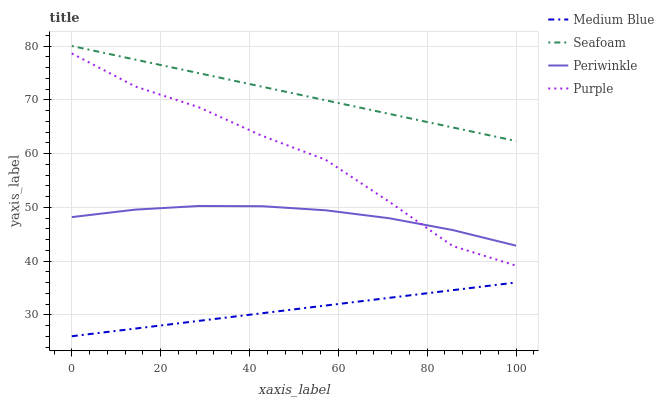Does Medium Blue have the minimum area under the curve?
Answer yes or no. Yes. Does Seafoam have the maximum area under the curve?
Answer yes or no. Yes. Does Periwinkle have the minimum area under the curve?
Answer yes or no. No. Does Periwinkle have the maximum area under the curve?
Answer yes or no. No. Is Medium Blue the smoothest?
Answer yes or no. Yes. Is Purple the roughest?
Answer yes or no. Yes. Is Periwinkle the smoothest?
Answer yes or no. No. Is Periwinkle the roughest?
Answer yes or no. No. Does Medium Blue have the lowest value?
Answer yes or no. Yes. Does Periwinkle have the lowest value?
Answer yes or no. No. Does Seafoam have the highest value?
Answer yes or no. Yes. Does Periwinkle have the highest value?
Answer yes or no. No. Is Purple less than Seafoam?
Answer yes or no. Yes. Is Seafoam greater than Periwinkle?
Answer yes or no. Yes. Does Purple intersect Periwinkle?
Answer yes or no. Yes. Is Purple less than Periwinkle?
Answer yes or no. No. Is Purple greater than Periwinkle?
Answer yes or no. No. Does Purple intersect Seafoam?
Answer yes or no. No. 